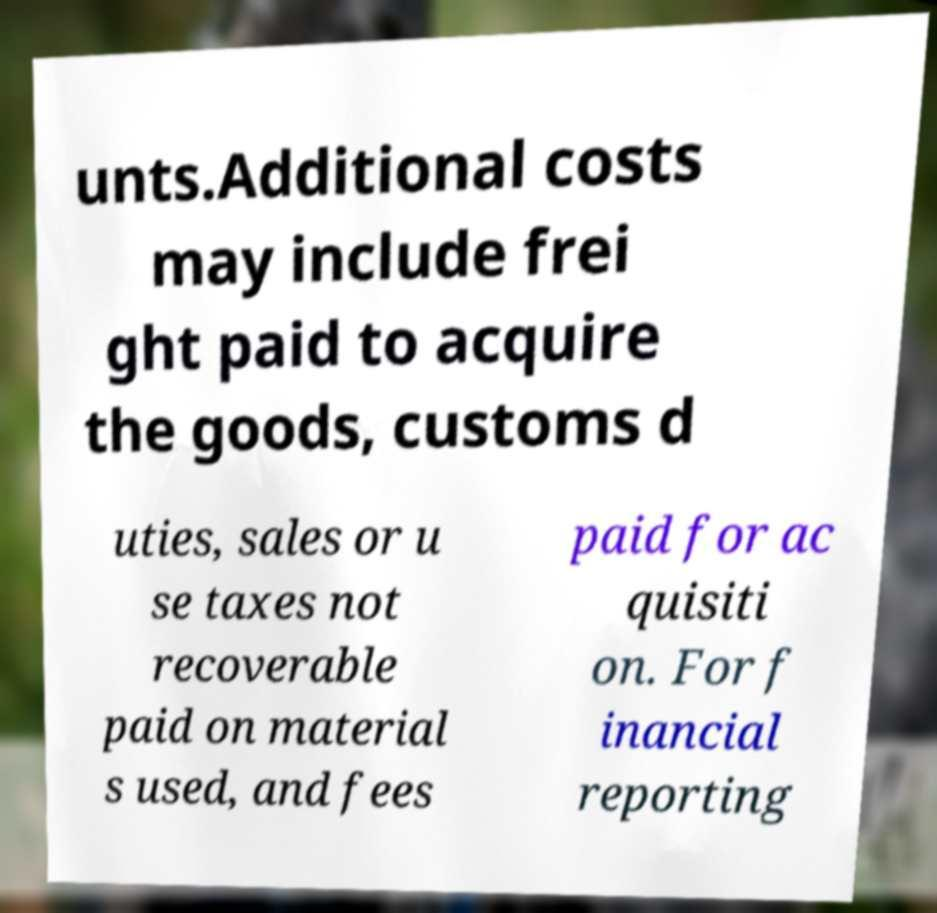Could you extract and type out the text from this image? unts.Additional costs may include frei ght paid to acquire the goods, customs d uties, sales or u se taxes not recoverable paid on material s used, and fees paid for ac quisiti on. For f inancial reporting 